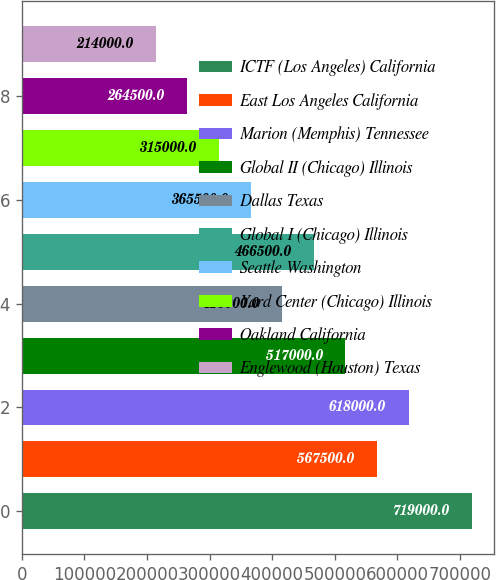Convert chart. <chart><loc_0><loc_0><loc_500><loc_500><bar_chart><fcel>ICTF (Los Angeles) California<fcel>East Los Angeles California<fcel>Marion (Memphis) Tennessee<fcel>Global II (Chicago) Illinois<fcel>Dallas Texas<fcel>Global I (Chicago) Illinois<fcel>Seattle Washington<fcel>Yard Center (Chicago) Illinois<fcel>Oakland California<fcel>Englewood (Houston) Texas<nl><fcel>719000<fcel>567500<fcel>618000<fcel>517000<fcel>416000<fcel>466500<fcel>365500<fcel>315000<fcel>264500<fcel>214000<nl></chart> 